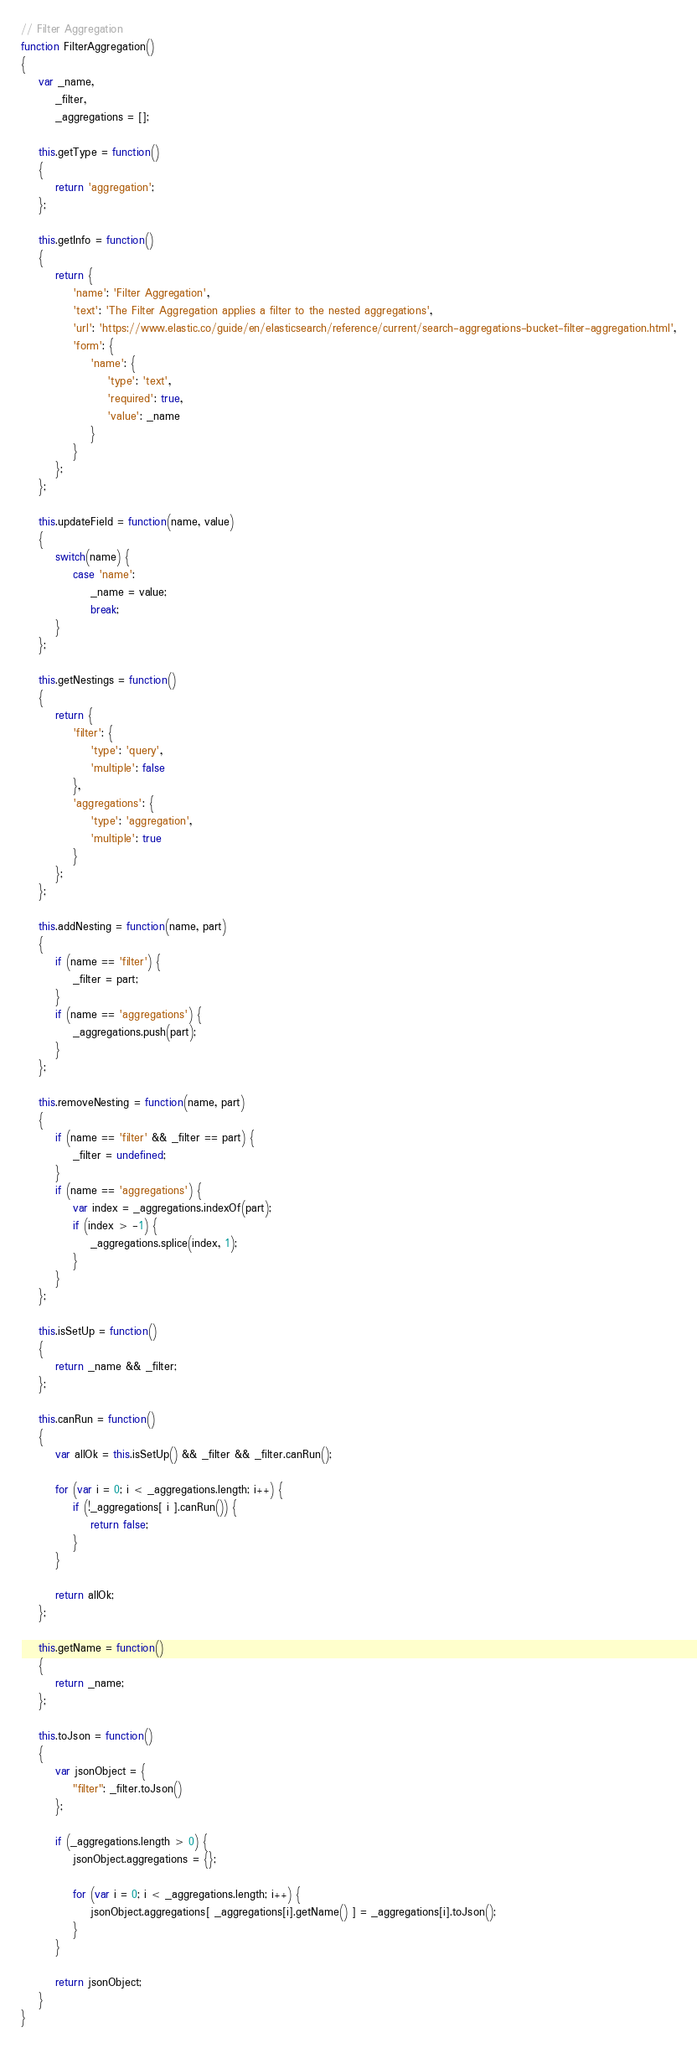<code> <loc_0><loc_0><loc_500><loc_500><_JavaScript_>// Filter Aggregation
function FilterAggregation()
{
	var _name,
		_filter,
		_aggregations = [];

	this.getType = function()
	{
		return 'aggregation';
	};

	this.getInfo = function()
	{
		return {
			'name': 'Filter Aggregation',
			'text': 'The Filter Aggregation applies a filter to the nested aggregations',
			'url': 'https://www.elastic.co/guide/en/elasticsearch/reference/current/search-aggregations-bucket-filter-aggregation.html',
			'form': {
				'name': {
					'type': 'text',
					'required': true,
					'value': _name
				}
			}
		};
	};

	this.updateField = function(name, value)
	{
		switch(name) {
			case 'name':
				_name = value;
				break;
		}
	};

	this.getNestings = function()
	{
		return {
			'filter': {
				'type': 'query',
				'multiple': false
			},
			'aggregations': {
				'type': 'aggregation',
				'multiple': true
			}
		};
	};

	this.addNesting = function(name, part)
	{
		if (name == 'filter') {
			_filter = part;
		}
		if (name == 'aggregations') {
			_aggregations.push(part);
		}
	};

	this.removeNesting = function(name, part)
	{
		if (name == 'filter' && _filter == part) {
			_filter = undefined;
		}
		if (name == 'aggregations') {
			var index = _aggregations.indexOf(part);
			if (index > -1) {
				_aggregations.splice(index, 1);
			}
		}
	};

	this.isSetUp = function()
	{
		return _name && _filter;
	};

	this.canRun = function()
	{
		var allOk = this.isSetUp() && _filter && _filter.canRun();

		for (var i = 0; i < _aggregations.length; i++) {
			if (!_aggregations[ i ].canRun()) {
				return false;
			}
		}

		return allOk;
	};

	this.getName = function()
	{
		return _name;
	};

	this.toJson = function()
	{
		var jsonObject = {
			"filter": _filter.toJson()
		};

		if (_aggregations.length > 0) {
			jsonObject.aggregations = {};

			for (var i = 0; i < _aggregations.length; i++) {
				jsonObject.aggregations[ _aggregations[i].getName() ] = _aggregations[i].toJson();
			}
		}

		return jsonObject;
	}
}
</code> 